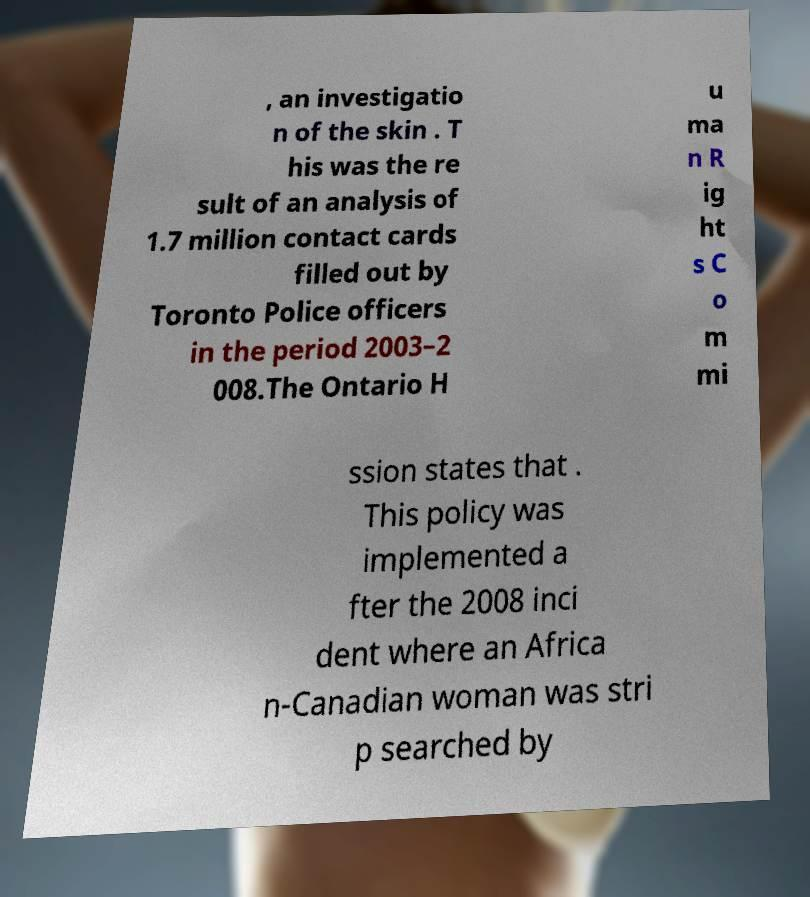Can you read and provide the text displayed in the image?This photo seems to have some interesting text. Can you extract and type it out for me? , an investigatio n of the skin . T his was the re sult of an analysis of 1.7 million contact cards filled out by Toronto Police officers in the period 2003–2 008.The Ontario H u ma n R ig ht s C o m mi ssion states that . This policy was implemented a fter the 2008 inci dent where an Africa n-Canadian woman was stri p searched by 